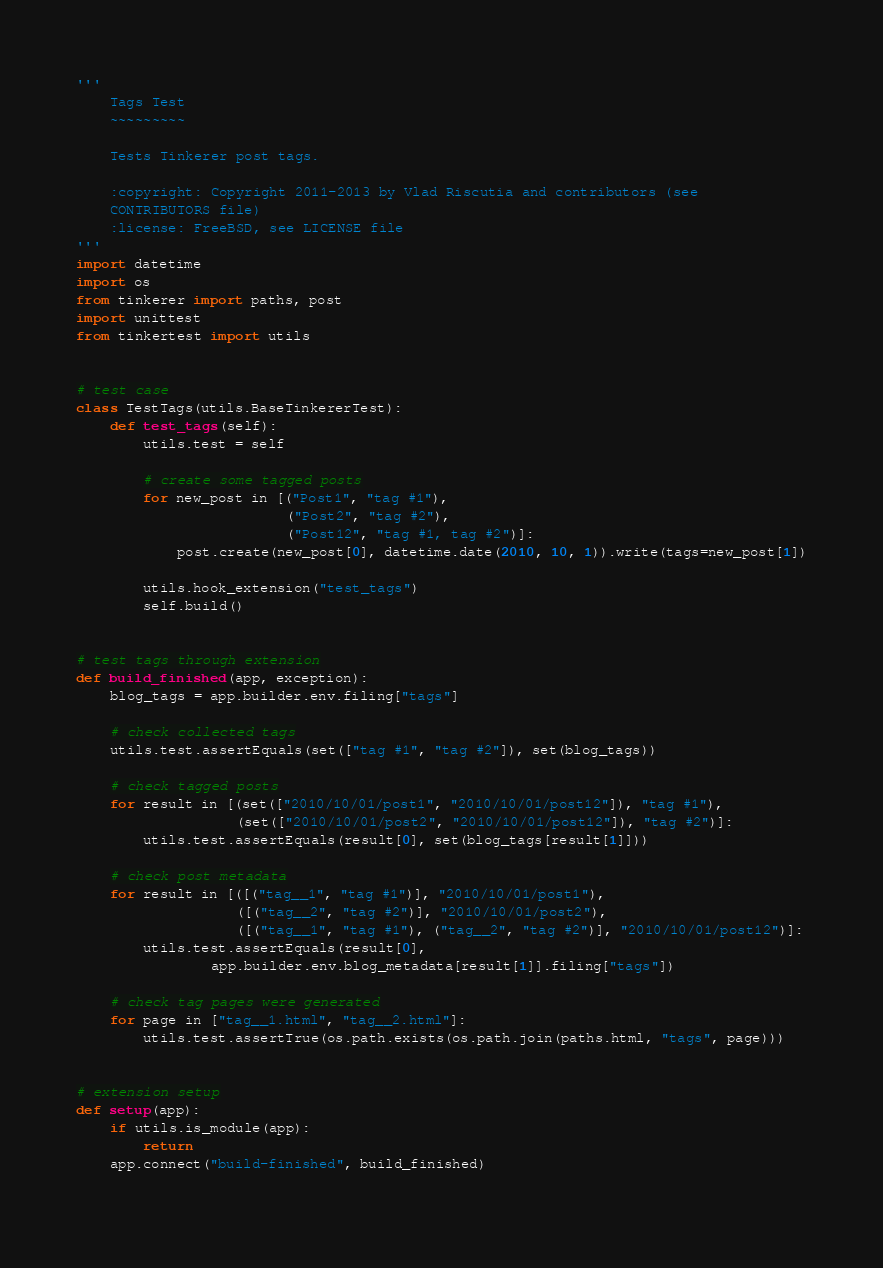Convert code to text. <code><loc_0><loc_0><loc_500><loc_500><_Python_>'''
    Tags Test
    ~~~~~~~~~

    Tests Tinkerer post tags.

    :copyright: Copyright 2011-2013 by Vlad Riscutia and contributors (see
    CONTRIBUTORS file)
    :license: FreeBSD, see LICENSE file
'''
import datetime
import os
from tinkerer import paths, post
import unittest
from tinkertest import utils


# test case
class TestTags(utils.BaseTinkererTest):
    def test_tags(self):
        utils.test = self

        # create some tagged posts
        for new_post in [("Post1", "tag #1"),
                         ("Post2", "tag #2"),
                         ("Post12", "tag #1, tag #2")]:
            post.create(new_post[0], datetime.date(2010, 10, 1)).write(tags=new_post[1])

        utils.hook_extension("test_tags")
        self.build()


# test tags through extension
def build_finished(app, exception):
    blog_tags = app.builder.env.filing["tags"]

    # check collected tags
    utils.test.assertEquals(set(["tag #1", "tag #2"]), set(blog_tags))

    # check tagged posts
    for result in [(set(["2010/10/01/post1", "2010/10/01/post12"]), "tag #1"),
                   (set(["2010/10/01/post2", "2010/10/01/post12"]), "tag #2")]:
        utils.test.assertEquals(result[0], set(blog_tags[result[1]]))

    # check post metadata
    for result in [([("tag__1", "tag #1")], "2010/10/01/post1"),
                   ([("tag__2", "tag #2")], "2010/10/01/post2"),
                   ([("tag__1", "tag #1"), ("tag__2", "tag #2")], "2010/10/01/post12")]:
        utils.test.assertEquals(result[0], 
                app.builder.env.blog_metadata[result[1]].filing["tags"])

    # check tag pages were generated
    for page in ["tag__1.html", "tag__2.html"]:
        utils.test.assertTrue(os.path.exists(os.path.join(paths.html, "tags", page)))


# extension setup
def setup(app):
    if utils.is_module(app):
        return
    app.connect("build-finished", build_finished)
 
</code> 